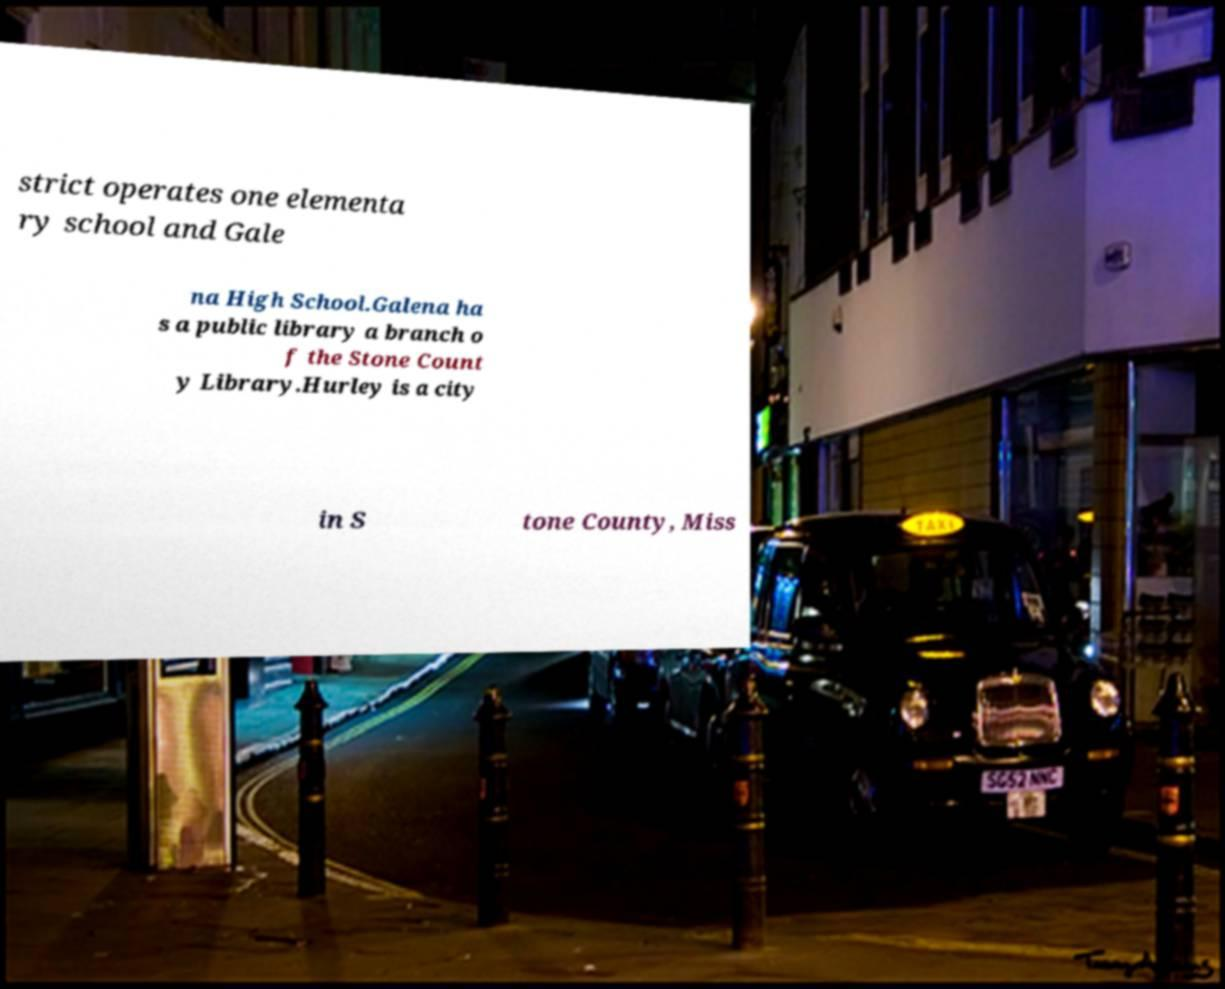Can you read and provide the text displayed in the image?This photo seems to have some interesting text. Can you extract and type it out for me? strict operates one elementa ry school and Gale na High School.Galena ha s a public library a branch o f the Stone Count y Library.Hurley is a city in S tone County, Miss 